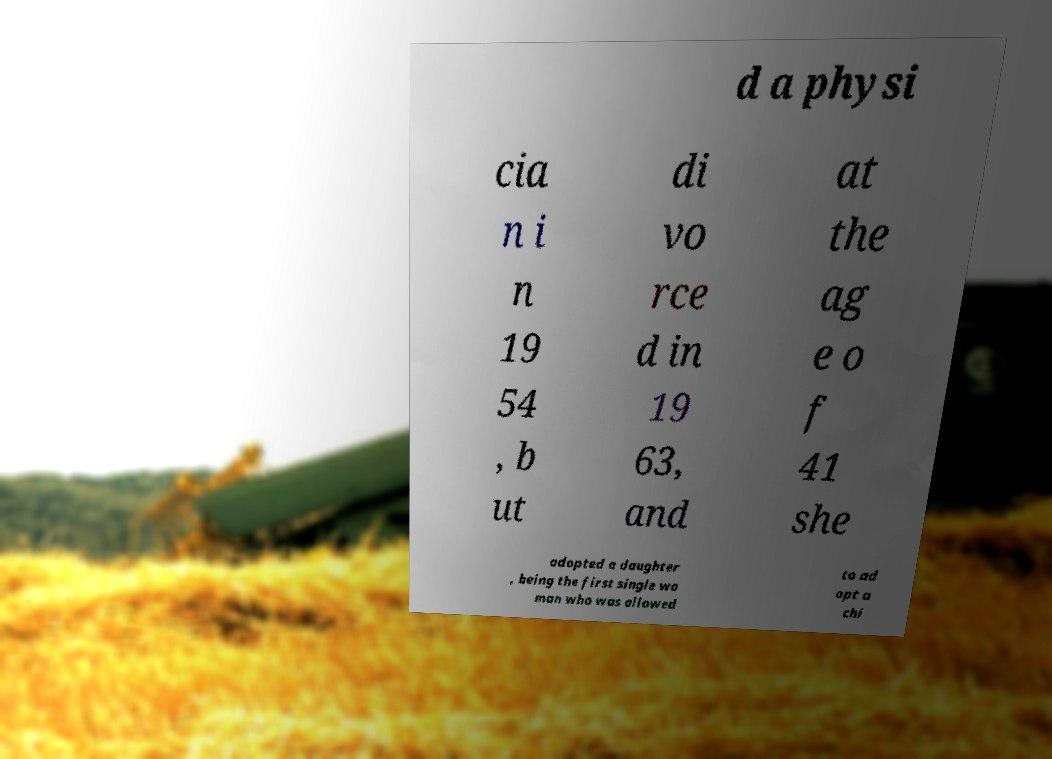Could you assist in decoding the text presented in this image and type it out clearly? d a physi cia n i n 19 54 , b ut di vo rce d in 19 63, and at the ag e o f 41 she adopted a daughter , being the first single wo man who was allowed to ad opt a chi 